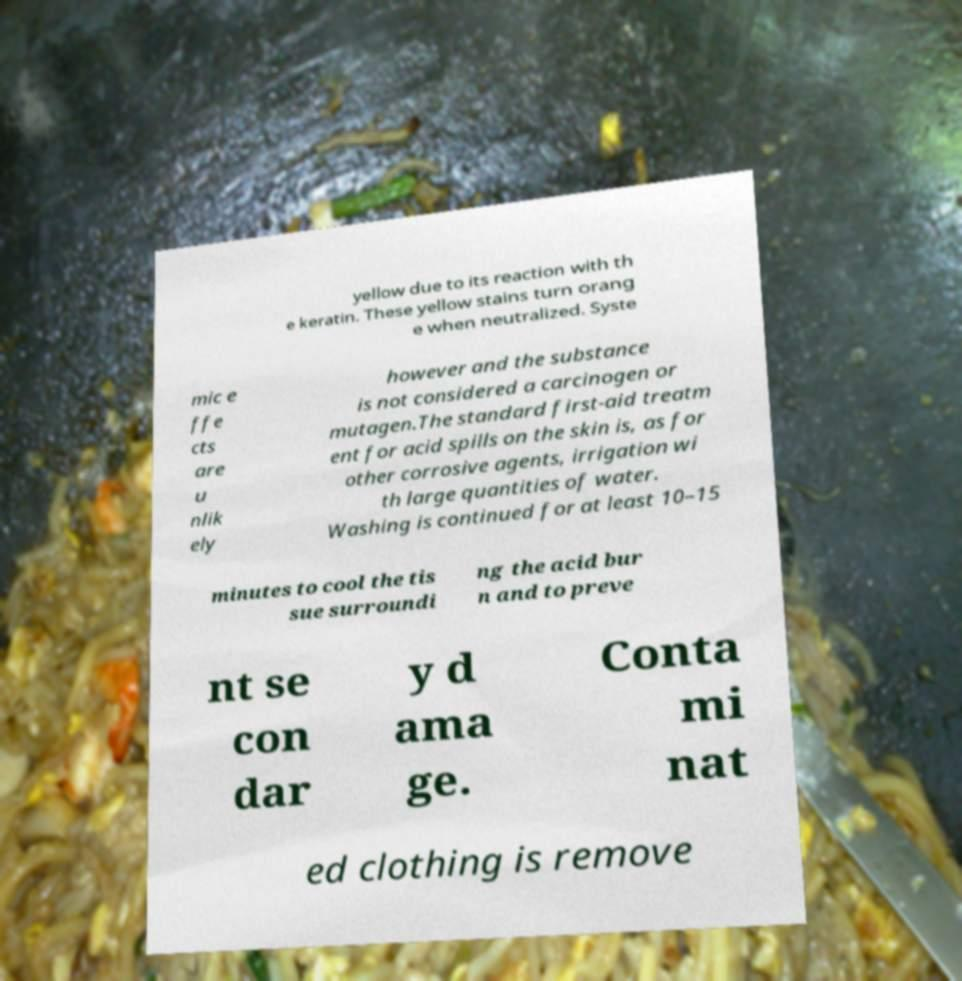For documentation purposes, I need the text within this image transcribed. Could you provide that? yellow due to its reaction with th e keratin. These yellow stains turn orang e when neutralized. Syste mic e ffe cts are u nlik ely however and the substance is not considered a carcinogen or mutagen.The standard first-aid treatm ent for acid spills on the skin is, as for other corrosive agents, irrigation wi th large quantities of water. Washing is continued for at least 10–15 minutes to cool the tis sue surroundi ng the acid bur n and to preve nt se con dar y d ama ge. Conta mi nat ed clothing is remove 